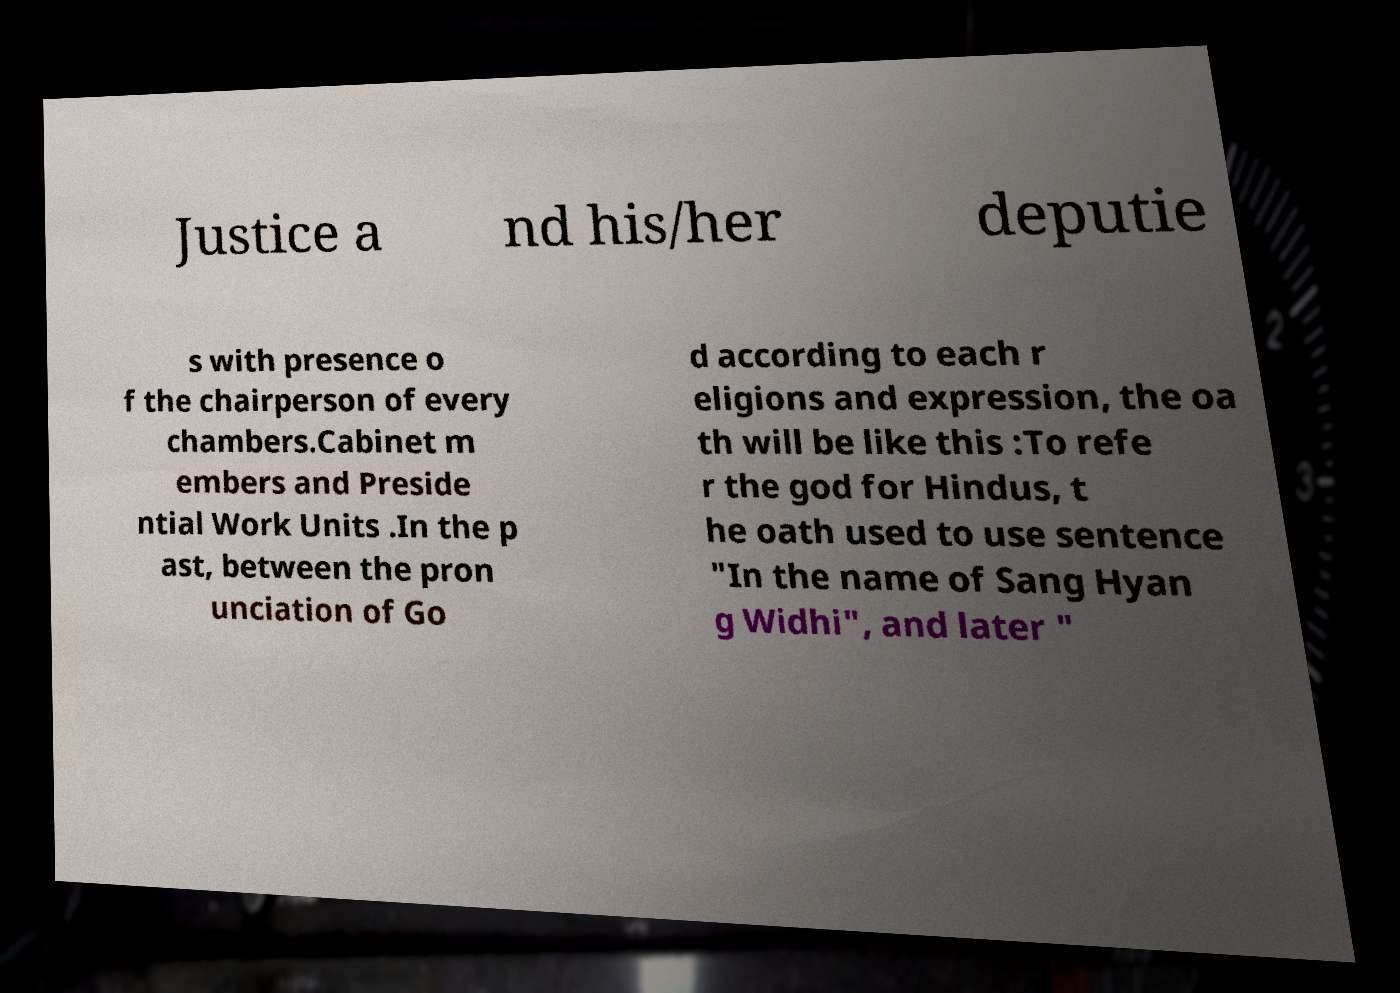Can you accurately transcribe the text from the provided image for me? Justice a nd his/her deputie s with presence o f the chairperson of every chambers.Cabinet m embers and Preside ntial Work Units .In the p ast, between the pron unciation of Go d according to each r eligions and expression, the oa th will be like this :To refe r the god for Hindus, t he oath used to use sentence "In the name of Sang Hyan g Widhi", and later " 